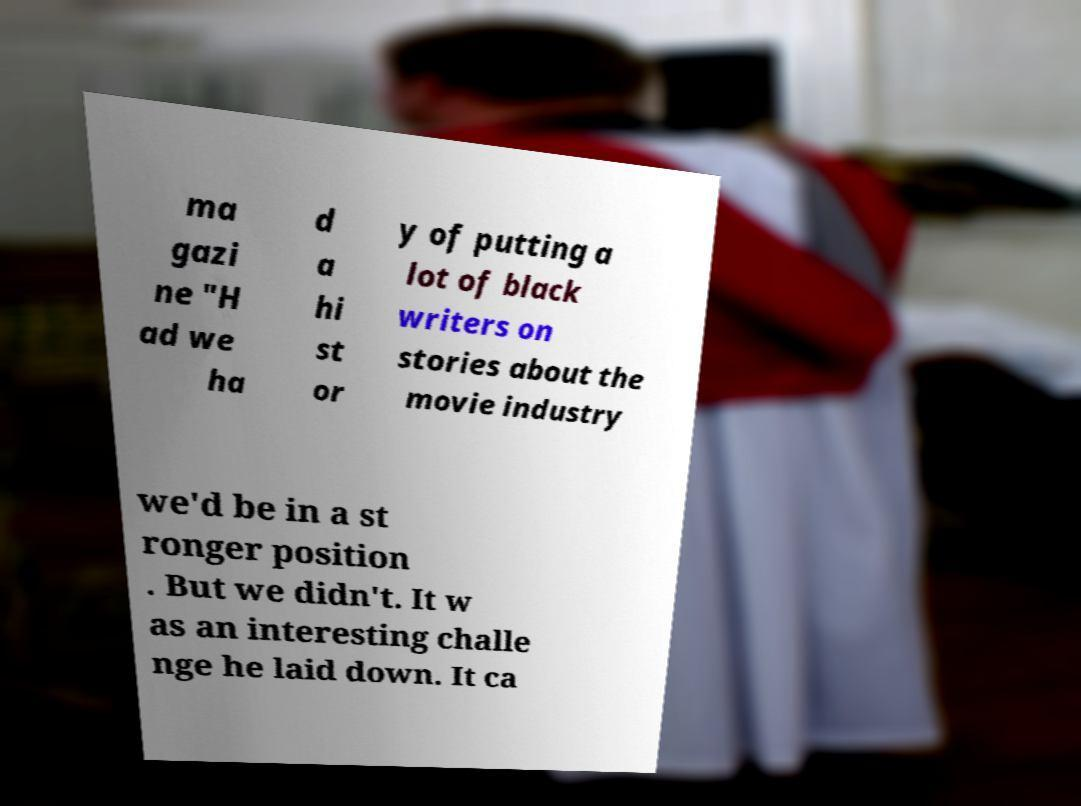For documentation purposes, I need the text within this image transcribed. Could you provide that? ma gazi ne "H ad we ha d a hi st or y of putting a lot of black writers on stories about the movie industry we'd be in a st ronger position . But we didn't. It w as an interesting challe nge he laid down. It ca 